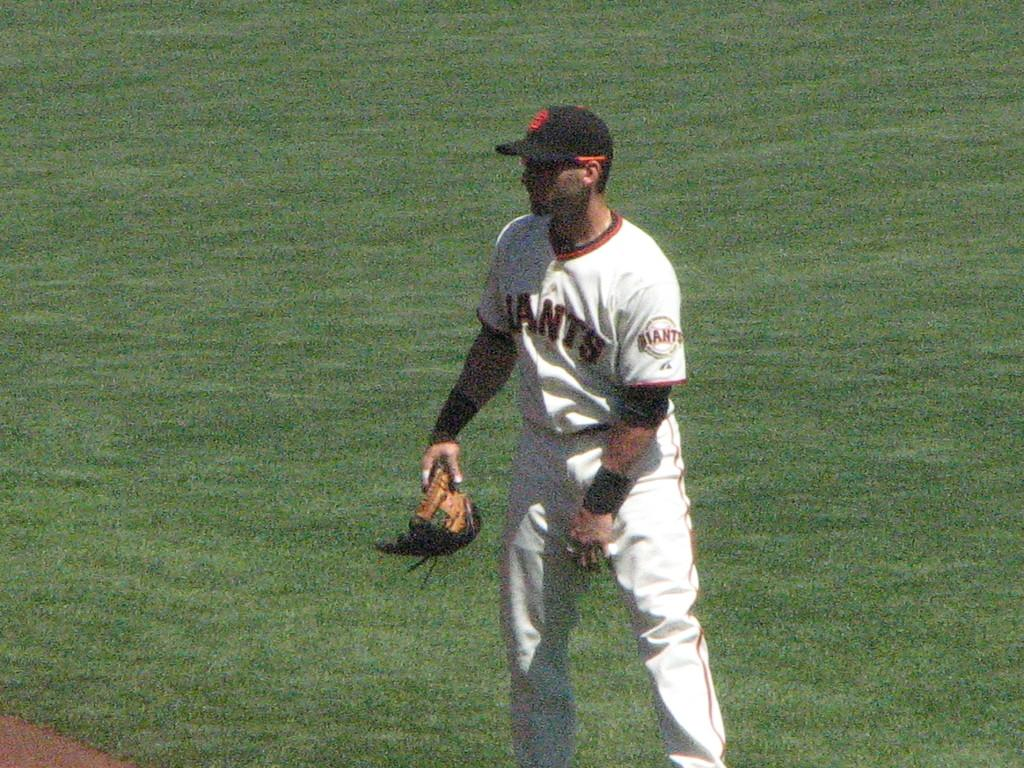Who is present in the image? There is a man in the image. What is the man doing in the image? The man is standing on the ground. What is the man wearing in the image? The man is wearing a white dress and a black cap. What type of juice is the man holding in the image? There is no juice present in the image; the man is not holding any beverage. 